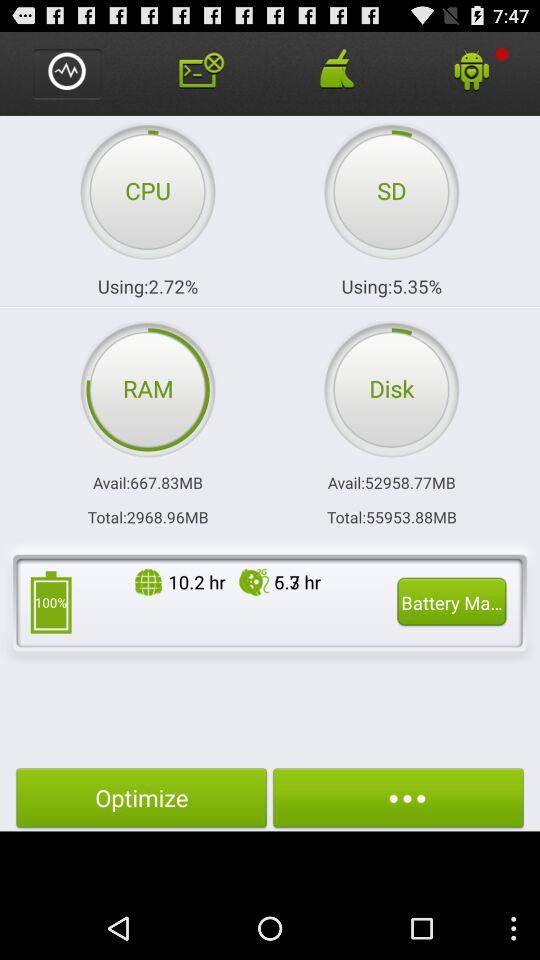What percentage of battery is remaining? The remaining battery percentage is 100. 